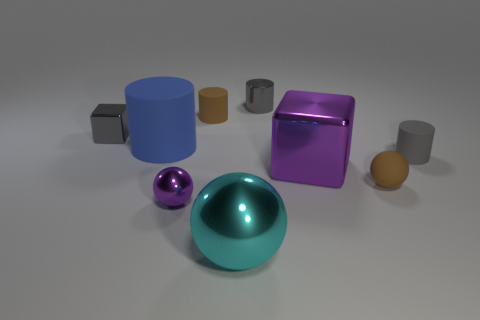Can you describe the texture of the objects varying in size and color in the image? Certainly! The objects vary not only in size and color but also in texture. The large cyan cylinder and the large blue cube both present a smooth, metallic gloss, while the smaller, spherical, and cuboid objects display a more matte or satin finish. Their textures suggest a combination of polished and brushed surfaces. 